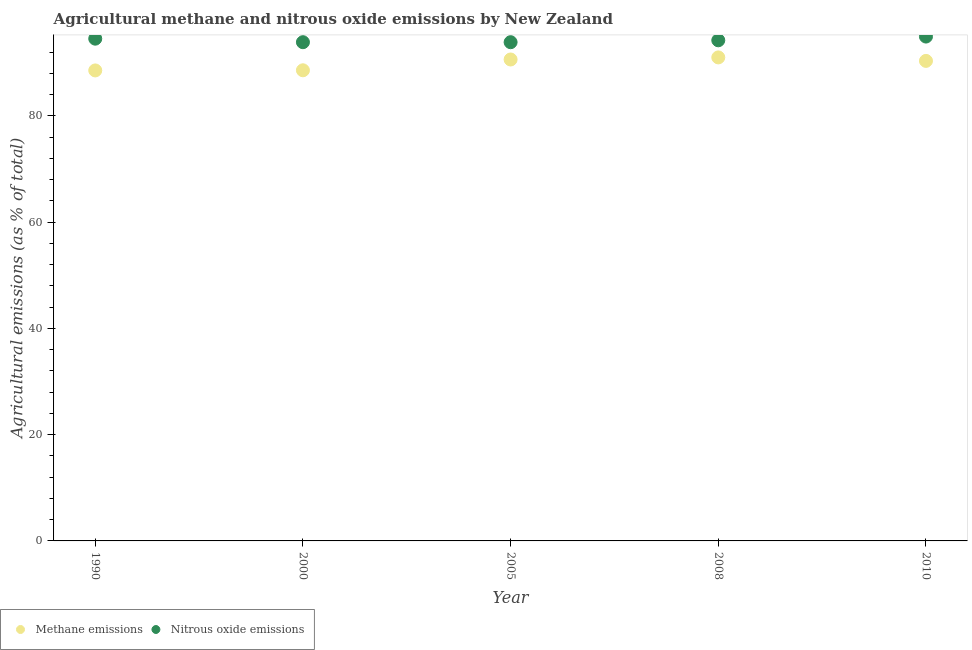Is the number of dotlines equal to the number of legend labels?
Give a very brief answer. Yes. What is the amount of methane emissions in 2010?
Make the answer very short. 90.33. Across all years, what is the maximum amount of methane emissions?
Keep it short and to the point. 90.99. Across all years, what is the minimum amount of nitrous oxide emissions?
Provide a short and direct response. 93.85. In which year was the amount of methane emissions maximum?
Give a very brief answer. 2008. What is the total amount of methane emissions in the graph?
Your response must be concise. 449.01. What is the difference between the amount of methane emissions in 1990 and that in 2008?
Provide a succinct answer. -2.45. What is the difference between the amount of methane emissions in 2010 and the amount of nitrous oxide emissions in 2008?
Your answer should be compact. -3.88. What is the average amount of methane emissions per year?
Provide a short and direct response. 89.8. In the year 1990, what is the difference between the amount of nitrous oxide emissions and amount of methane emissions?
Your answer should be compact. 5.98. In how many years, is the amount of nitrous oxide emissions greater than 60 %?
Your answer should be very brief. 5. What is the ratio of the amount of nitrous oxide emissions in 2000 to that in 2010?
Offer a terse response. 0.99. What is the difference between the highest and the second highest amount of methane emissions?
Provide a succinct answer. 0.39. What is the difference between the highest and the lowest amount of nitrous oxide emissions?
Keep it short and to the point. 1.06. In how many years, is the amount of methane emissions greater than the average amount of methane emissions taken over all years?
Give a very brief answer. 3. Does the amount of methane emissions monotonically increase over the years?
Your response must be concise. No. Is the amount of methane emissions strictly greater than the amount of nitrous oxide emissions over the years?
Offer a terse response. No. Is the amount of methane emissions strictly less than the amount of nitrous oxide emissions over the years?
Offer a very short reply. Yes. How many dotlines are there?
Provide a short and direct response. 2. How many years are there in the graph?
Your response must be concise. 5. What is the difference between two consecutive major ticks on the Y-axis?
Your answer should be very brief. 20. Are the values on the major ticks of Y-axis written in scientific E-notation?
Your response must be concise. No. Does the graph contain grids?
Your response must be concise. No. Where does the legend appear in the graph?
Your answer should be very brief. Bottom left. How are the legend labels stacked?
Your answer should be very brief. Horizontal. What is the title of the graph?
Provide a succinct answer. Agricultural methane and nitrous oxide emissions by New Zealand. What is the label or title of the X-axis?
Give a very brief answer. Year. What is the label or title of the Y-axis?
Give a very brief answer. Agricultural emissions (as % of total). What is the Agricultural emissions (as % of total) of Methane emissions in 1990?
Offer a very short reply. 88.54. What is the Agricultural emissions (as % of total) in Nitrous oxide emissions in 1990?
Ensure brevity in your answer.  94.51. What is the Agricultural emissions (as % of total) in Methane emissions in 2000?
Ensure brevity in your answer.  88.56. What is the Agricultural emissions (as % of total) in Nitrous oxide emissions in 2000?
Give a very brief answer. 93.85. What is the Agricultural emissions (as % of total) of Methane emissions in 2005?
Offer a very short reply. 90.59. What is the Agricultural emissions (as % of total) of Nitrous oxide emissions in 2005?
Your answer should be compact. 93.85. What is the Agricultural emissions (as % of total) in Methane emissions in 2008?
Your answer should be very brief. 90.99. What is the Agricultural emissions (as % of total) in Nitrous oxide emissions in 2008?
Ensure brevity in your answer.  94.21. What is the Agricultural emissions (as % of total) of Methane emissions in 2010?
Ensure brevity in your answer.  90.33. What is the Agricultural emissions (as % of total) in Nitrous oxide emissions in 2010?
Keep it short and to the point. 94.91. Across all years, what is the maximum Agricultural emissions (as % of total) in Methane emissions?
Keep it short and to the point. 90.99. Across all years, what is the maximum Agricultural emissions (as % of total) of Nitrous oxide emissions?
Provide a short and direct response. 94.91. Across all years, what is the minimum Agricultural emissions (as % of total) in Methane emissions?
Make the answer very short. 88.54. Across all years, what is the minimum Agricultural emissions (as % of total) of Nitrous oxide emissions?
Your response must be concise. 93.85. What is the total Agricultural emissions (as % of total) in Methane emissions in the graph?
Provide a short and direct response. 449.01. What is the total Agricultural emissions (as % of total) in Nitrous oxide emissions in the graph?
Your answer should be very brief. 471.32. What is the difference between the Agricultural emissions (as % of total) of Methane emissions in 1990 and that in 2000?
Make the answer very short. -0.03. What is the difference between the Agricultural emissions (as % of total) in Nitrous oxide emissions in 1990 and that in 2000?
Your response must be concise. 0.66. What is the difference between the Agricultural emissions (as % of total) in Methane emissions in 1990 and that in 2005?
Your response must be concise. -2.06. What is the difference between the Agricultural emissions (as % of total) in Nitrous oxide emissions in 1990 and that in 2005?
Provide a succinct answer. 0.66. What is the difference between the Agricultural emissions (as % of total) in Methane emissions in 1990 and that in 2008?
Give a very brief answer. -2.45. What is the difference between the Agricultural emissions (as % of total) of Nitrous oxide emissions in 1990 and that in 2008?
Give a very brief answer. 0.3. What is the difference between the Agricultural emissions (as % of total) in Methane emissions in 1990 and that in 2010?
Provide a succinct answer. -1.79. What is the difference between the Agricultural emissions (as % of total) of Nitrous oxide emissions in 1990 and that in 2010?
Offer a very short reply. -0.4. What is the difference between the Agricultural emissions (as % of total) of Methane emissions in 2000 and that in 2005?
Provide a succinct answer. -2.03. What is the difference between the Agricultural emissions (as % of total) of Nitrous oxide emissions in 2000 and that in 2005?
Provide a short and direct response. 0. What is the difference between the Agricultural emissions (as % of total) of Methane emissions in 2000 and that in 2008?
Your answer should be compact. -2.42. What is the difference between the Agricultural emissions (as % of total) in Nitrous oxide emissions in 2000 and that in 2008?
Your answer should be very brief. -0.36. What is the difference between the Agricultural emissions (as % of total) of Methane emissions in 2000 and that in 2010?
Your answer should be compact. -1.77. What is the difference between the Agricultural emissions (as % of total) in Nitrous oxide emissions in 2000 and that in 2010?
Provide a short and direct response. -1.06. What is the difference between the Agricultural emissions (as % of total) of Methane emissions in 2005 and that in 2008?
Offer a very short reply. -0.39. What is the difference between the Agricultural emissions (as % of total) of Nitrous oxide emissions in 2005 and that in 2008?
Make the answer very short. -0.36. What is the difference between the Agricultural emissions (as % of total) in Methane emissions in 2005 and that in 2010?
Ensure brevity in your answer.  0.27. What is the difference between the Agricultural emissions (as % of total) in Nitrous oxide emissions in 2005 and that in 2010?
Your response must be concise. -1.06. What is the difference between the Agricultural emissions (as % of total) of Methane emissions in 2008 and that in 2010?
Offer a terse response. 0.66. What is the difference between the Agricultural emissions (as % of total) of Nitrous oxide emissions in 2008 and that in 2010?
Make the answer very short. -0.7. What is the difference between the Agricultural emissions (as % of total) of Methane emissions in 1990 and the Agricultural emissions (as % of total) of Nitrous oxide emissions in 2000?
Offer a very short reply. -5.31. What is the difference between the Agricultural emissions (as % of total) in Methane emissions in 1990 and the Agricultural emissions (as % of total) in Nitrous oxide emissions in 2005?
Provide a succinct answer. -5.31. What is the difference between the Agricultural emissions (as % of total) of Methane emissions in 1990 and the Agricultural emissions (as % of total) of Nitrous oxide emissions in 2008?
Your answer should be compact. -5.67. What is the difference between the Agricultural emissions (as % of total) of Methane emissions in 1990 and the Agricultural emissions (as % of total) of Nitrous oxide emissions in 2010?
Your answer should be very brief. -6.37. What is the difference between the Agricultural emissions (as % of total) in Methane emissions in 2000 and the Agricultural emissions (as % of total) in Nitrous oxide emissions in 2005?
Ensure brevity in your answer.  -5.28. What is the difference between the Agricultural emissions (as % of total) of Methane emissions in 2000 and the Agricultural emissions (as % of total) of Nitrous oxide emissions in 2008?
Make the answer very short. -5.64. What is the difference between the Agricultural emissions (as % of total) of Methane emissions in 2000 and the Agricultural emissions (as % of total) of Nitrous oxide emissions in 2010?
Your answer should be compact. -6.35. What is the difference between the Agricultural emissions (as % of total) of Methane emissions in 2005 and the Agricultural emissions (as % of total) of Nitrous oxide emissions in 2008?
Your answer should be compact. -3.61. What is the difference between the Agricultural emissions (as % of total) of Methane emissions in 2005 and the Agricultural emissions (as % of total) of Nitrous oxide emissions in 2010?
Offer a terse response. -4.31. What is the difference between the Agricultural emissions (as % of total) of Methane emissions in 2008 and the Agricultural emissions (as % of total) of Nitrous oxide emissions in 2010?
Offer a terse response. -3.92. What is the average Agricultural emissions (as % of total) of Methane emissions per year?
Provide a succinct answer. 89.8. What is the average Agricultural emissions (as % of total) of Nitrous oxide emissions per year?
Keep it short and to the point. 94.26. In the year 1990, what is the difference between the Agricultural emissions (as % of total) of Methane emissions and Agricultural emissions (as % of total) of Nitrous oxide emissions?
Offer a terse response. -5.98. In the year 2000, what is the difference between the Agricultural emissions (as % of total) in Methane emissions and Agricultural emissions (as % of total) in Nitrous oxide emissions?
Give a very brief answer. -5.29. In the year 2005, what is the difference between the Agricultural emissions (as % of total) of Methane emissions and Agricultural emissions (as % of total) of Nitrous oxide emissions?
Make the answer very short. -3.25. In the year 2008, what is the difference between the Agricultural emissions (as % of total) of Methane emissions and Agricultural emissions (as % of total) of Nitrous oxide emissions?
Your response must be concise. -3.22. In the year 2010, what is the difference between the Agricultural emissions (as % of total) of Methane emissions and Agricultural emissions (as % of total) of Nitrous oxide emissions?
Your answer should be compact. -4.58. What is the ratio of the Agricultural emissions (as % of total) in Methane emissions in 1990 to that in 2000?
Offer a very short reply. 1. What is the ratio of the Agricultural emissions (as % of total) of Nitrous oxide emissions in 1990 to that in 2000?
Your answer should be compact. 1.01. What is the ratio of the Agricultural emissions (as % of total) in Methane emissions in 1990 to that in 2005?
Your answer should be compact. 0.98. What is the ratio of the Agricultural emissions (as % of total) in Nitrous oxide emissions in 1990 to that in 2005?
Your answer should be compact. 1.01. What is the ratio of the Agricultural emissions (as % of total) in Methane emissions in 1990 to that in 2008?
Ensure brevity in your answer.  0.97. What is the ratio of the Agricultural emissions (as % of total) in Methane emissions in 1990 to that in 2010?
Offer a terse response. 0.98. What is the ratio of the Agricultural emissions (as % of total) of Methane emissions in 2000 to that in 2005?
Give a very brief answer. 0.98. What is the ratio of the Agricultural emissions (as % of total) in Methane emissions in 2000 to that in 2008?
Ensure brevity in your answer.  0.97. What is the ratio of the Agricultural emissions (as % of total) of Nitrous oxide emissions in 2000 to that in 2008?
Provide a short and direct response. 1. What is the ratio of the Agricultural emissions (as % of total) of Methane emissions in 2000 to that in 2010?
Provide a succinct answer. 0.98. What is the ratio of the Agricultural emissions (as % of total) in Nitrous oxide emissions in 2000 to that in 2010?
Give a very brief answer. 0.99. What is the ratio of the Agricultural emissions (as % of total) of Methane emissions in 2005 to that in 2008?
Ensure brevity in your answer.  1. What is the ratio of the Agricultural emissions (as % of total) in Methane emissions in 2005 to that in 2010?
Your response must be concise. 1. What is the ratio of the Agricultural emissions (as % of total) in Methane emissions in 2008 to that in 2010?
Your response must be concise. 1.01. What is the difference between the highest and the second highest Agricultural emissions (as % of total) in Methane emissions?
Your answer should be very brief. 0.39. What is the difference between the highest and the second highest Agricultural emissions (as % of total) in Nitrous oxide emissions?
Keep it short and to the point. 0.4. What is the difference between the highest and the lowest Agricultural emissions (as % of total) in Methane emissions?
Offer a very short reply. 2.45. What is the difference between the highest and the lowest Agricultural emissions (as % of total) of Nitrous oxide emissions?
Provide a short and direct response. 1.06. 